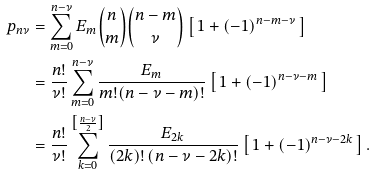<formula> <loc_0><loc_0><loc_500><loc_500>p _ { n \nu } & = \sum _ { m = 0 } ^ { n - \nu } E _ { m } \binom { n } { m } \binom { n - m } { \nu } \left [ \, 1 + ( - 1 ) ^ { n - m - \nu } \, \right ] \\ & = \frac { n ! } { \nu ! } \sum _ { m = 0 } ^ { n - \nu } \frac { E _ { m } } { m ! ( n - \nu - m ) ! } \left [ \, 1 + ( - 1 ) ^ { n - \nu - m } \, \right ] \\ & = \frac { n ! } { \nu ! } \sum _ { k = 0 } ^ { \left [ \frac { n - \nu } { 2 } \right ] } \frac { E _ { 2 k } } { ( 2 k ) ! \, ( n - \nu - 2 k ) ! } \left [ \, 1 + ( - 1 ) ^ { n - \nu - 2 k } \, \right ] .</formula> 